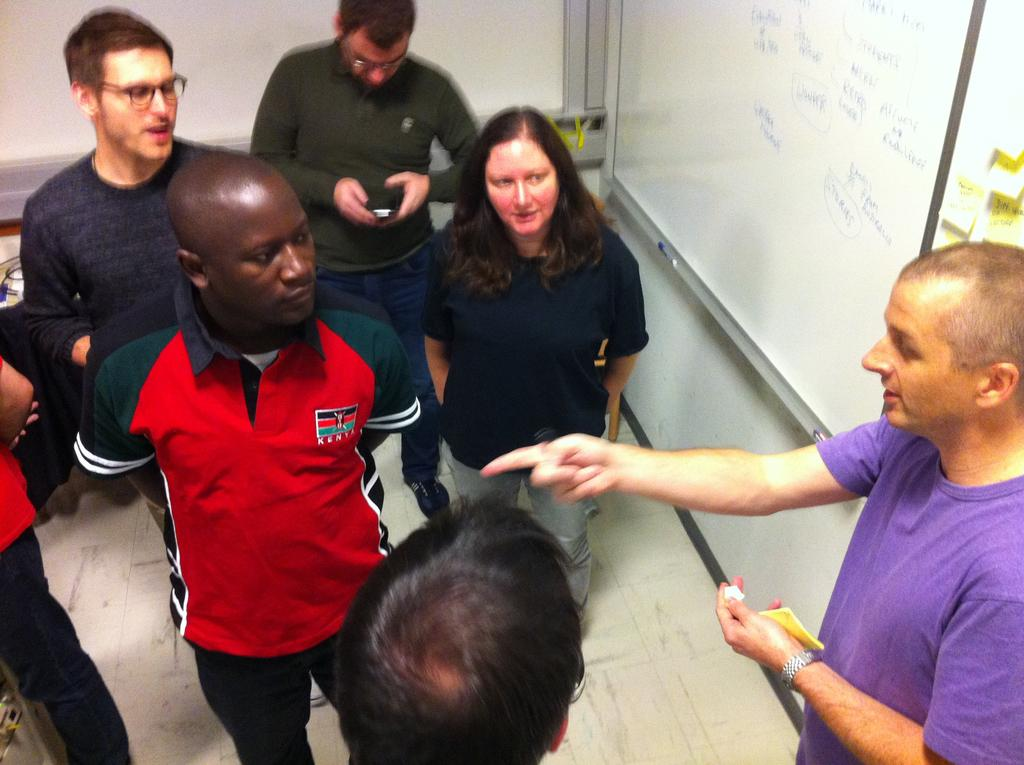What is the main object in the image? There is a board in the image. Who or what else is present in the image? There is a group of people in the image. Can you describe the actions of any individuals in the image? One person is holding a mobile phone. How many cakes are on the sign in the image? There is no sign or cakes present in the image. What type of toad can be seen hopping near the board in the image? There is no toad present in the image. 